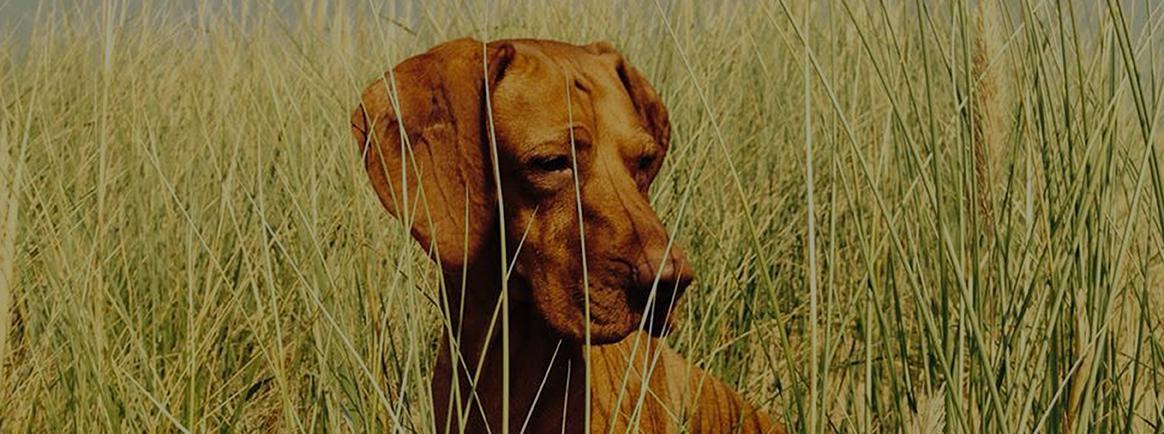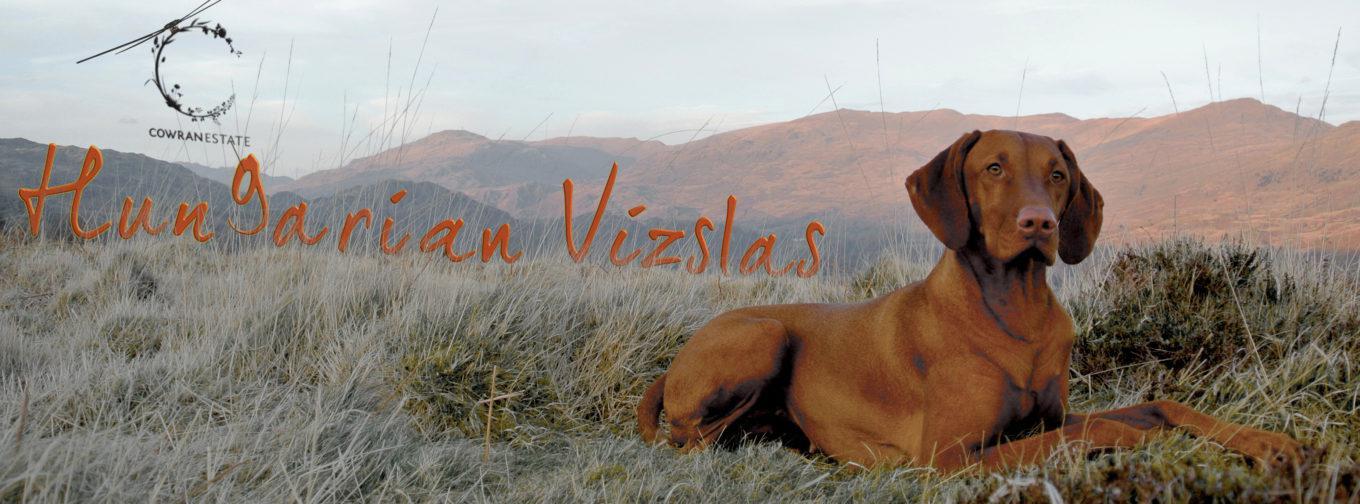The first image is the image on the left, the second image is the image on the right. For the images displayed, is the sentence "Each image contains one red-orange adult dog, and one image shows a dog in a black collar standing on all fours in the grass facing rightward." factually correct? Answer yes or no. No. The first image is the image on the left, the second image is the image on the right. Given the left and right images, does the statement "The dog in one of the images is standing in the grass." hold true? Answer yes or no. No. 